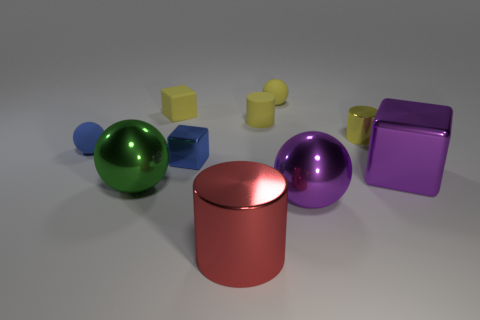There is a cylinder in front of the blue object left of the blue metal block; what is its color?
Make the answer very short. Red. What number of large green things are there?
Your response must be concise. 1. What number of things are both in front of the tiny yellow ball and to the left of the big metallic cube?
Make the answer very short. 8. Are there any other things that have the same shape as the blue shiny thing?
Give a very brief answer. Yes. There is a large cube; is its color the same as the metal cylinder that is behind the large green shiny object?
Offer a very short reply. No. There is a small metal thing behind the tiny metallic cube; what is its shape?
Keep it short and to the point. Cylinder. What number of other things are there of the same material as the tiny yellow cube
Offer a very short reply. 3. What is the material of the tiny blue block?
Your answer should be very brief. Metal. What number of big things are either purple rubber blocks or purple metal objects?
Offer a terse response. 2. There is a purple metal block; what number of big cylinders are to the left of it?
Your answer should be very brief. 1. 